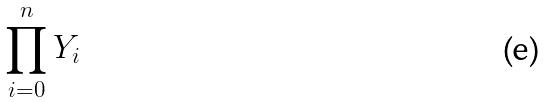<formula> <loc_0><loc_0><loc_500><loc_500>\prod _ { i = 0 } ^ { n } Y _ { i }</formula> 